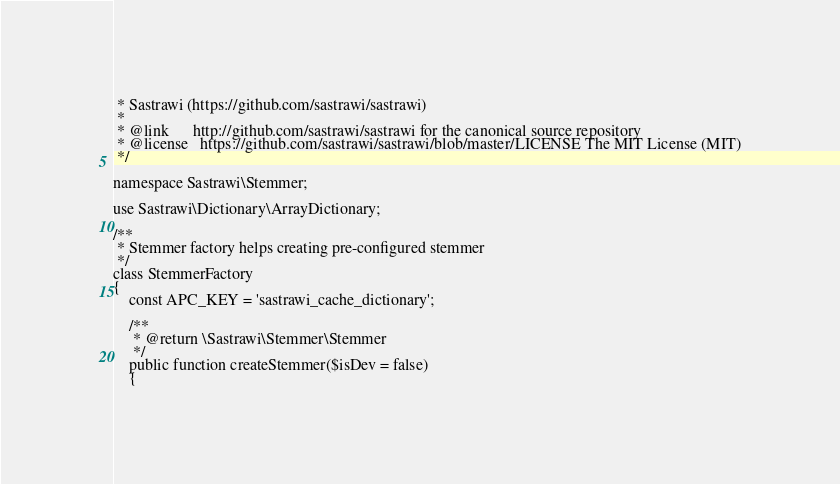<code> <loc_0><loc_0><loc_500><loc_500><_PHP_> * Sastrawi (https://github.com/sastrawi/sastrawi)
 *
 * @link      http://github.com/sastrawi/sastrawi for the canonical source repository
 * @license   https://github.com/sastrawi/sastrawi/blob/master/LICENSE The MIT License (MIT)
 */

namespace Sastrawi\Stemmer;

use Sastrawi\Dictionary\ArrayDictionary;

/**
 * Stemmer factory helps creating pre-configured stemmer
 */
class StemmerFactory
{
    const APC_KEY = 'sastrawi_cache_dictionary';

    /**
     * @return \Sastrawi\Stemmer\Stemmer
     */
    public function createStemmer($isDev = false)
    {</code> 